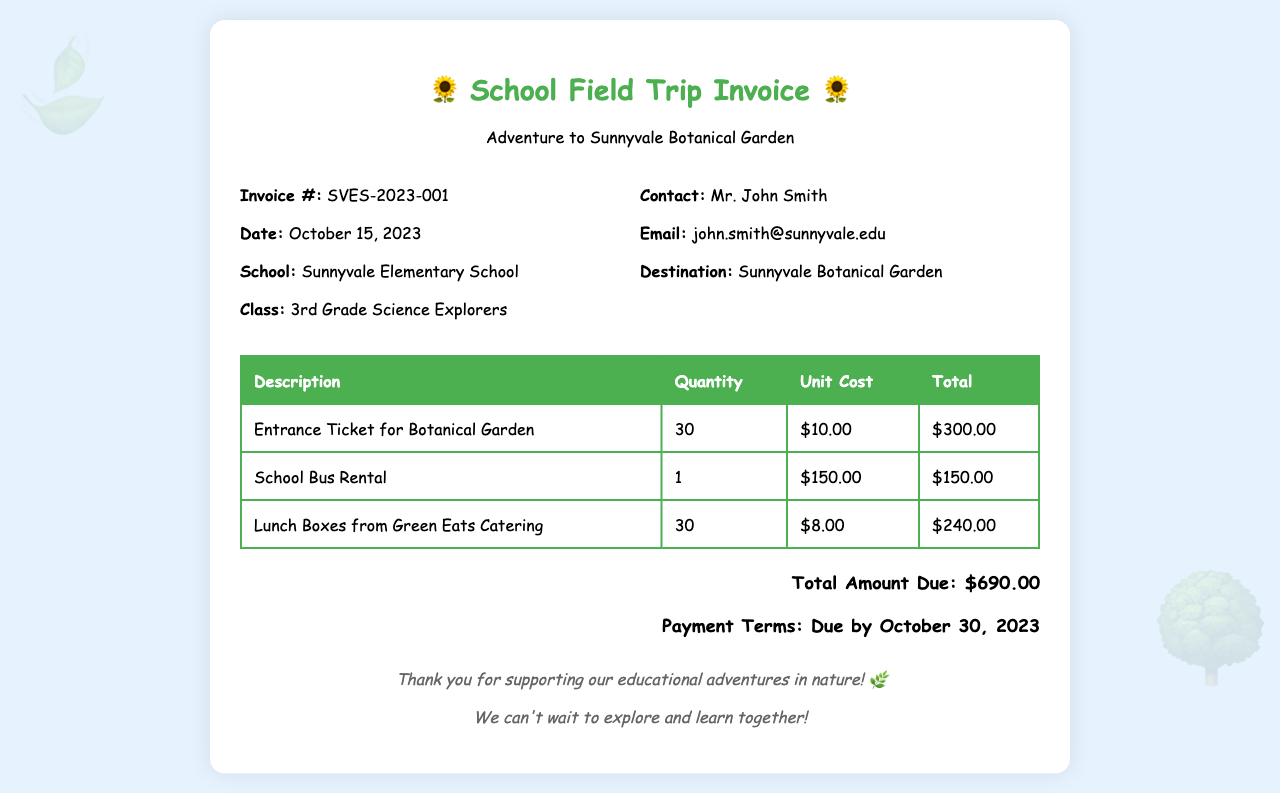What is the invoice number? The invoice number is a unique identifier for the document, which is SVES-2023-001.
Answer: SVES-2023-001 When is the payment due? The payment due date is mentioned in the document, which is October 30, 2023.
Answer: October 30, 2023 How many students are attending the trip? The number of students is reflected in the quantity of entrance tickets, which is 30.
Answer: 30 What is the total cost of the lunch boxes? The total cost of lunch boxes can be calculated from the unit cost and quantity, which gives a total of $240.00.
Answer: $240.00 Who is the contact person for this invoice? The document specifies that the contact person is Mr. John Smith.
Answer: Mr. John Smith What is the unit cost of one entrance ticket? The price for a single entrance ticket is indicated in the document as $10.00.
Answer: $10.00 What is the name of the catering service? The catering service mentioned for lunch boxes is Green Eats Catering.
Answer: Green Eats Catering What is the total amount due? The total amount due is the final figure provided in the invoice, which is $690.00.
Answer: $690.00 